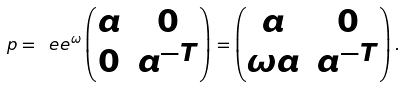Convert formula to latex. <formula><loc_0><loc_0><loc_500><loc_500>p = \ e e ^ { \omega } \begin{pmatrix} a & 0 \\ 0 & a ^ { - T } \end{pmatrix} = \begin{pmatrix} a & 0 \\ \omega a & a ^ { - T } \end{pmatrix} .</formula> 